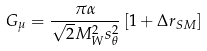Convert formula to latex. <formula><loc_0><loc_0><loc_500><loc_500>G _ { \mu } = \frac { \pi \alpha } { \sqrt { 2 } M _ { W } ^ { 2 } s _ { \theta } ^ { 2 } } \left [ 1 + \Delta r _ { S M } \right ]</formula> 